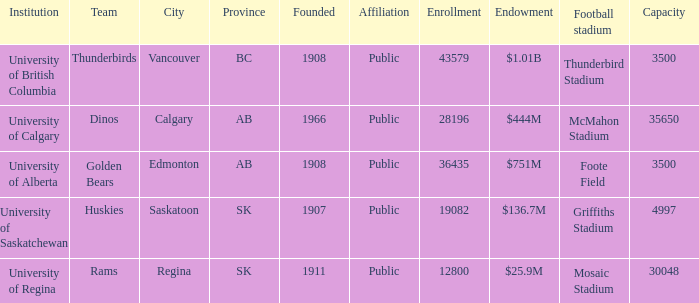What is the year founded for the team Dinos? 1966.0. 